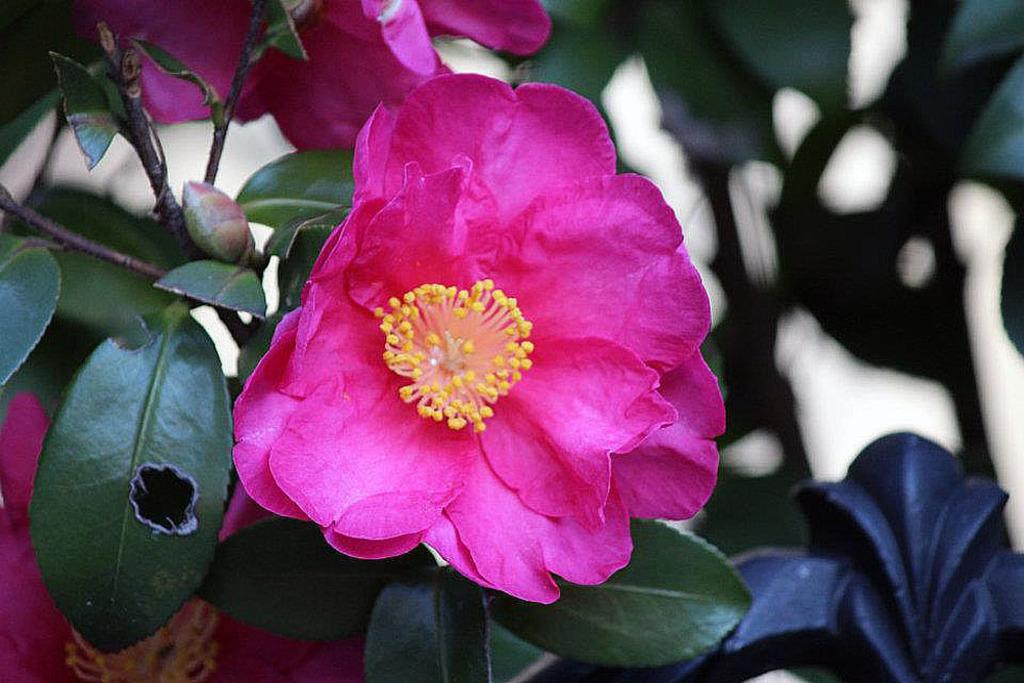How would you summarize this image in a sentence or two? In this image, we can see two pink color flowers and some green leaves. 